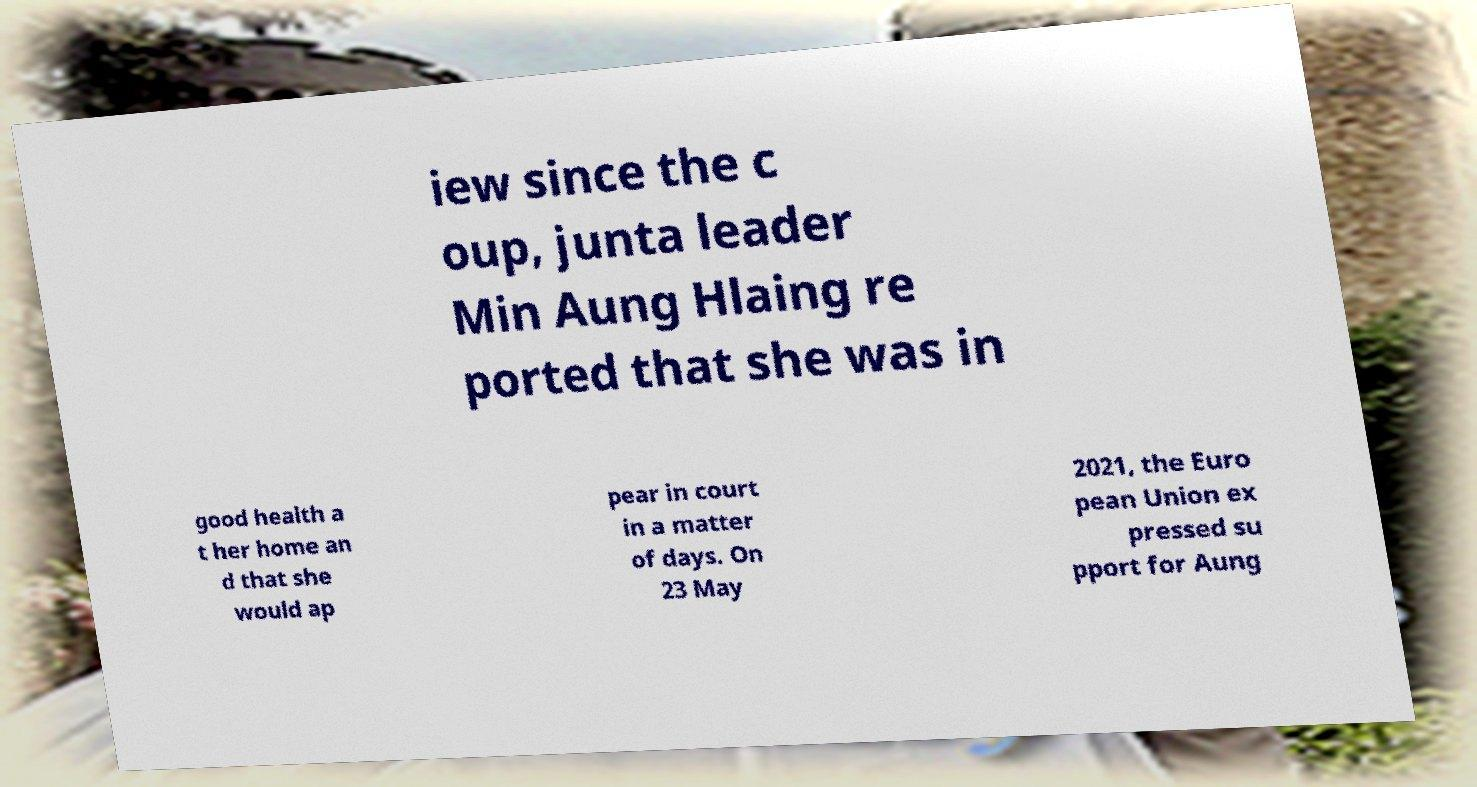There's text embedded in this image that I need extracted. Can you transcribe it verbatim? iew since the c oup, junta leader Min Aung Hlaing re ported that she was in good health a t her home an d that she would ap pear in court in a matter of days. On 23 May 2021, the Euro pean Union ex pressed su pport for Aung 